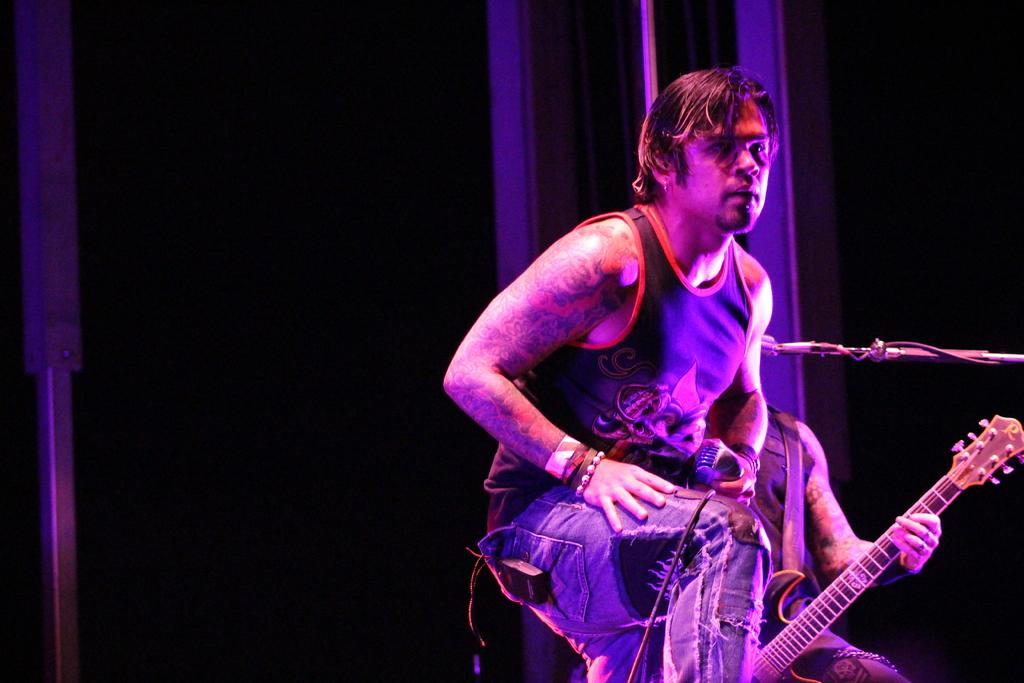What is the main subject of the image? There is a person in the image. What is the person wearing? The person is wearing clothes. What is the person holding in their hand? The person is holding a microphone in their hand. Can you describe the second person in the image? The second person is playing a guitar. How are the microphone and guitar positioned in relation to each other? The guitar is in front of the microphone. What type of hair is visible on the truck in the image? There is no truck present in the image, and therefore no hair can be observed on a truck. 